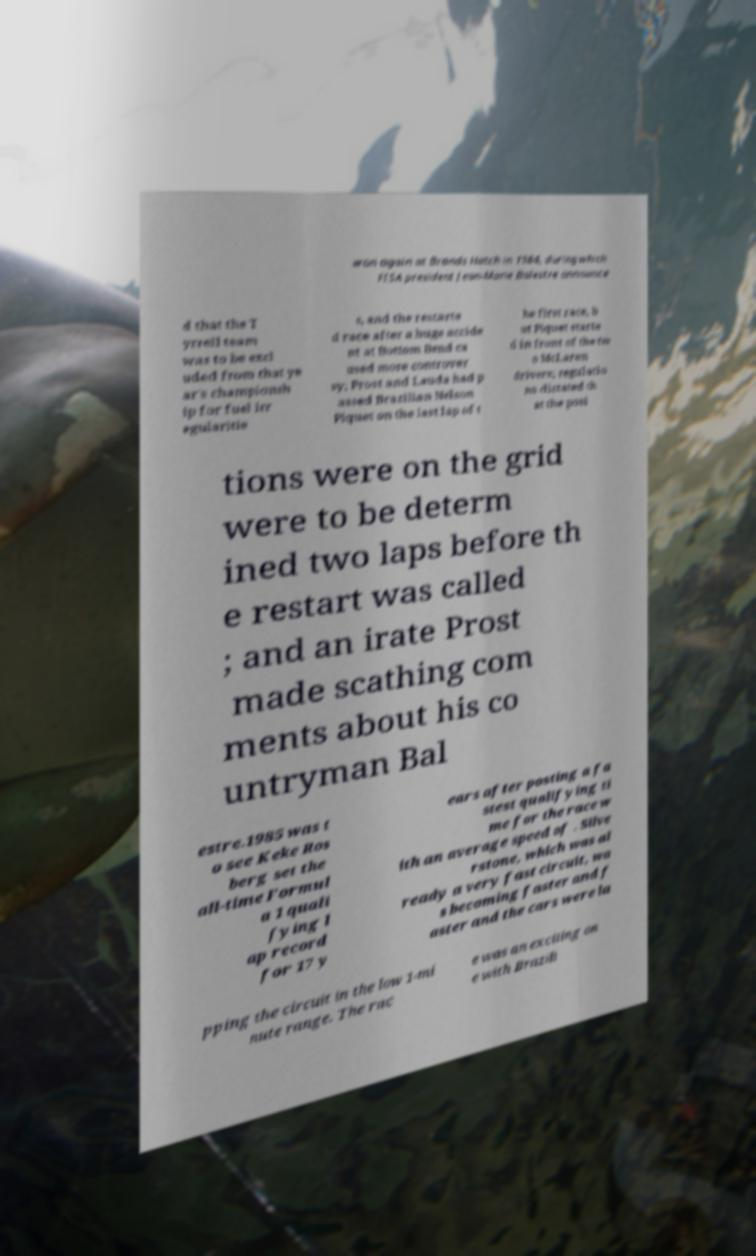What messages or text are displayed in this image? I need them in a readable, typed format. won again at Brands Hatch in 1984, during which FISA president Jean-Marie Balestre announce d that the T yrrell team was to be excl uded from that ye ar's championsh ip for fuel irr egularitie s, and the restarte d race after a huge accide nt at Bottom Bend ca used more controver sy; Prost and Lauda had p assed Brazilian Nelson Piquet on the last lap of t he first race, b ut Piquet starte d in front of the tw o McLaren drivers; regulatio ns dictated th at the posi tions were on the grid were to be determ ined two laps before th e restart was called ; and an irate Prost made scathing com ments about his co untryman Bal estre.1985 was t o see Keke Ros berg set the all-time Formul a 1 quali fying l ap record for 17 y ears after posting a fa stest qualifying ti me for the race w ith an average speed of . Silve rstone, which was al ready a very fast circuit, wa s becoming faster and f aster and the cars were la pping the circuit in the low 1-mi nute range. The rac e was an exciting on e with Brazili 